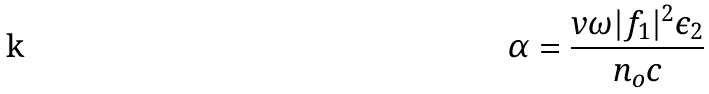<formula> <loc_0><loc_0><loc_500><loc_500>\alpha = \frac { v \omega | f _ { 1 } | ^ { 2 } \epsilon _ { 2 } } { n _ { o } c }</formula> 